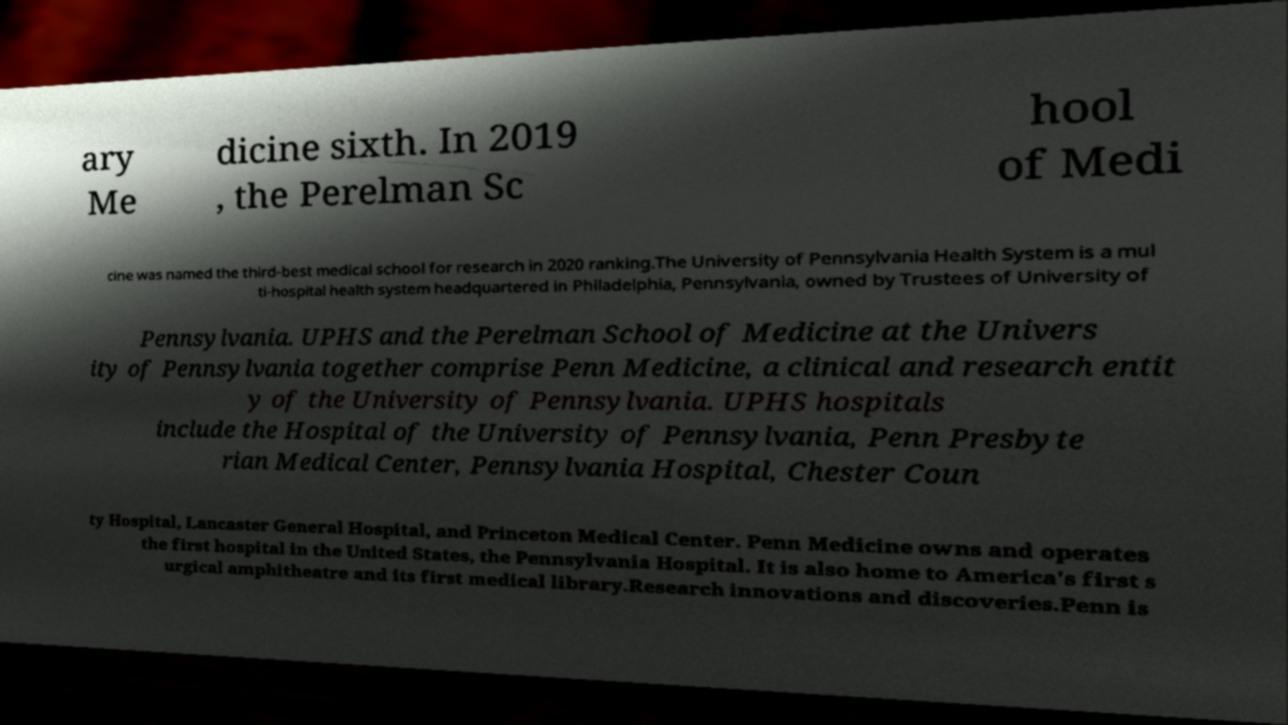For documentation purposes, I need the text within this image transcribed. Could you provide that? ary Me dicine sixth. In 2019 , the Perelman Sc hool of Medi cine was named the third-best medical school for research in 2020 ranking.The University of Pennsylvania Health System is a mul ti-hospital health system headquartered in Philadelphia, Pennsylvania, owned by Trustees of University of Pennsylvania. UPHS and the Perelman School of Medicine at the Univers ity of Pennsylvania together comprise Penn Medicine, a clinical and research entit y of the University of Pennsylvania. UPHS hospitals include the Hospital of the University of Pennsylvania, Penn Presbyte rian Medical Center, Pennsylvania Hospital, Chester Coun ty Hospital, Lancaster General Hospital, and Princeton Medical Center. Penn Medicine owns and operates the first hospital in the United States, the Pennsylvania Hospital. It is also home to America's first s urgical amphitheatre and its first medical library.Research innovations and discoveries.Penn is 